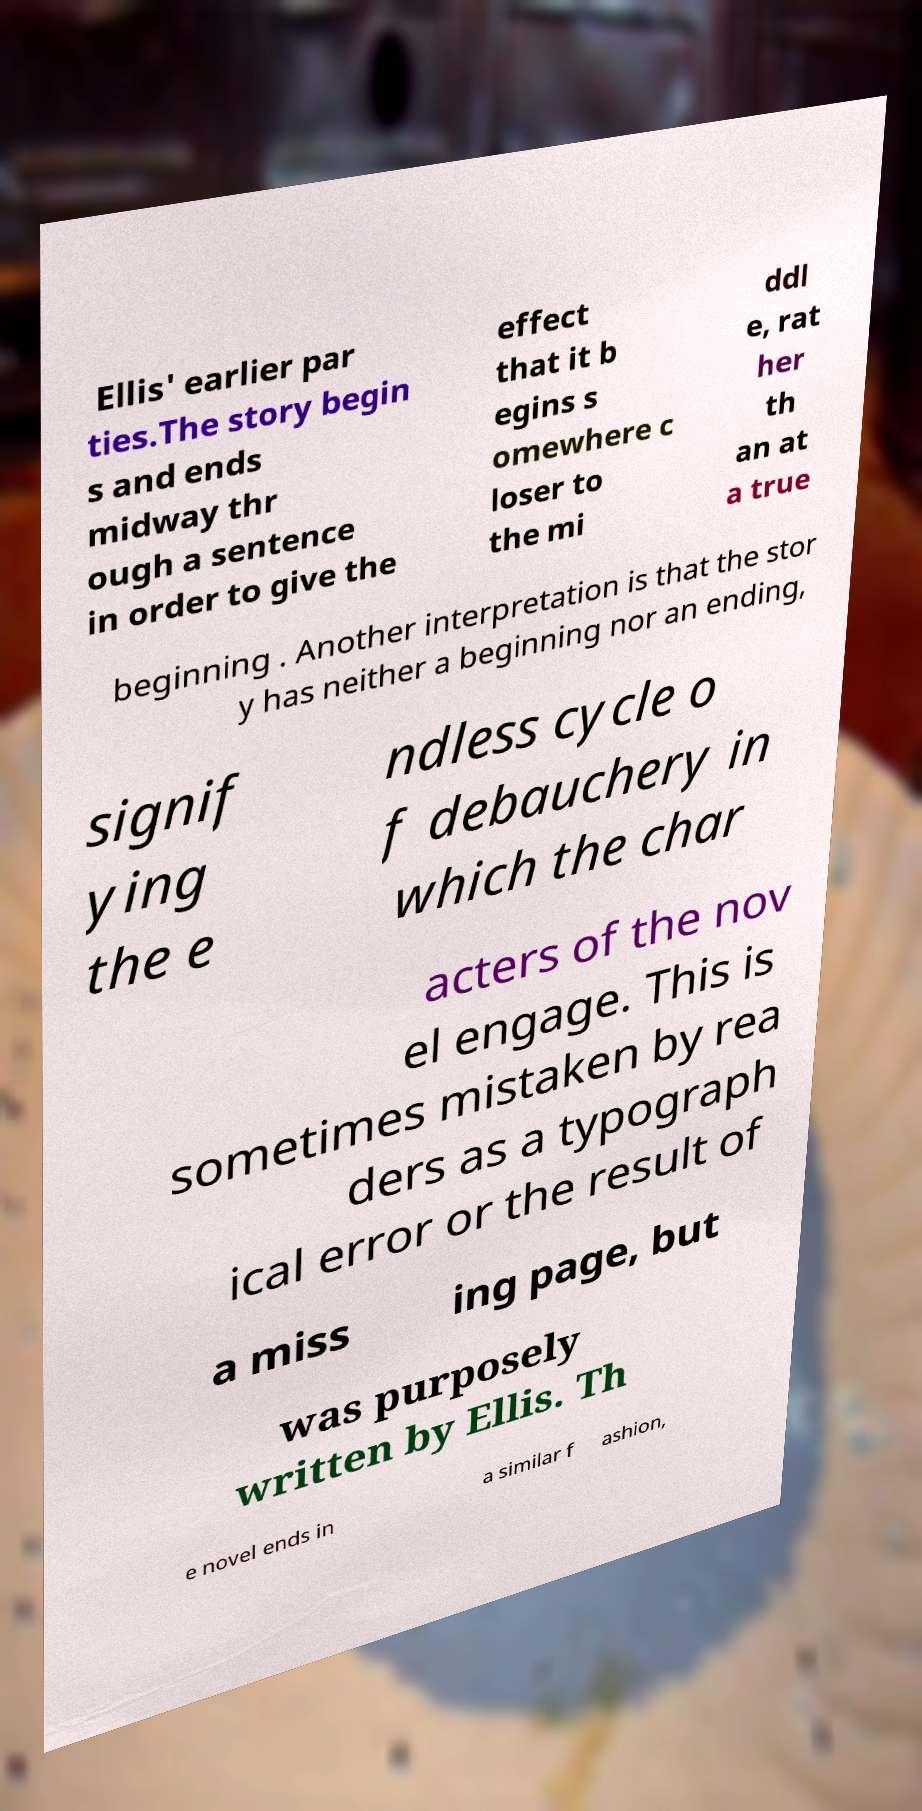Please read and relay the text visible in this image. What does it say? Ellis' earlier par ties.The story begin s and ends midway thr ough a sentence in order to give the effect that it b egins s omewhere c loser to the mi ddl e, rat her th an at a true beginning . Another interpretation is that the stor y has neither a beginning nor an ending, signif ying the e ndless cycle o f debauchery in which the char acters of the nov el engage. This is sometimes mistaken by rea ders as a typograph ical error or the result of a miss ing page, but was purposely written by Ellis. Th e novel ends in a similar f ashion, 